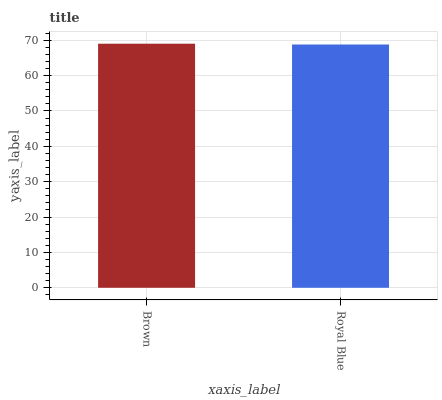Is Royal Blue the maximum?
Answer yes or no. No. Is Brown greater than Royal Blue?
Answer yes or no. Yes. Is Royal Blue less than Brown?
Answer yes or no. Yes. Is Royal Blue greater than Brown?
Answer yes or no. No. Is Brown less than Royal Blue?
Answer yes or no. No. Is Brown the high median?
Answer yes or no. Yes. Is Royal Blue the low median?
Answer yes or no. Yes. Is Royal Blue the high median?
Answer yes or no. No. Is Brown the low median?
Answer yes or no. No. 